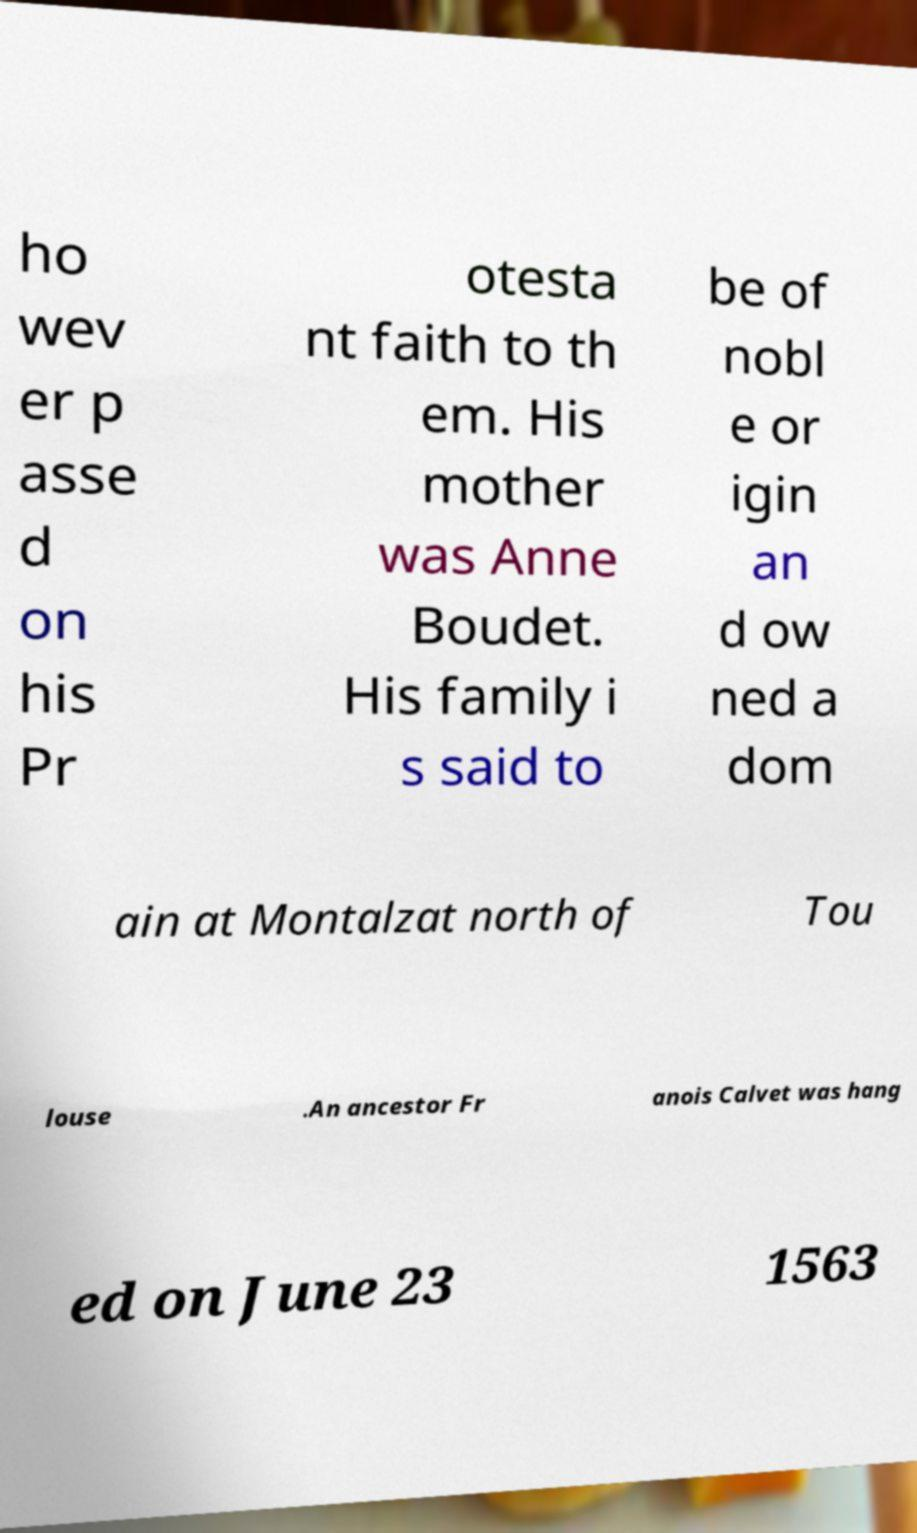What messages or text are displayed in this image? I need them in a readable, typed format. ho wev er p asse d on his Pr otesta nt faith to th em. His mother was Anne Boudet. His family i s said to be of nobl e or igin an d ow ned a dom ain at Montalzat north of Tou louse .An ancestor Fr anois Calvet was hang ed on June 23 1563 